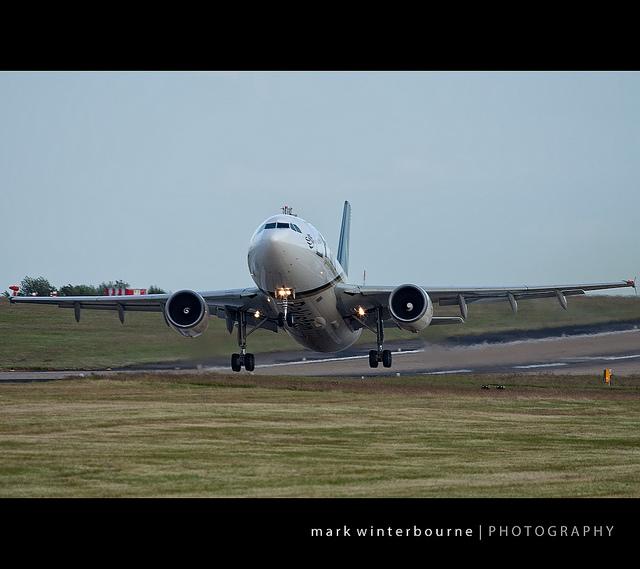Is this plane still being flown?
Write a very short answer. Yes. How many lights can you see on the plane?
Keep it brief. 3. Are the planes in motion?
Be succinct. Yes. What's the weather like?
Concise answer only. Clear. How many engines does the plane have?
Quick response, please. 2. Is the plan on concrete?
Answer briefly. No. Is the plane landing?
Give a very brief answer. No. 